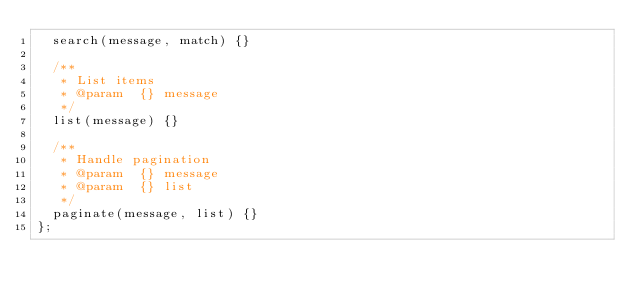<code> <loc_0><loc_0><loc_500><loc_500><_JavaScript_>	search(message, match) {}

	/**
	 * List items
	 * @param  {} message
	 */
	list(message) {}

	/**
	 * Handle pagination
	 * @param  {} message
	 * @param  {} list
	 */
	paginate(message, list) {}
};
</code> 